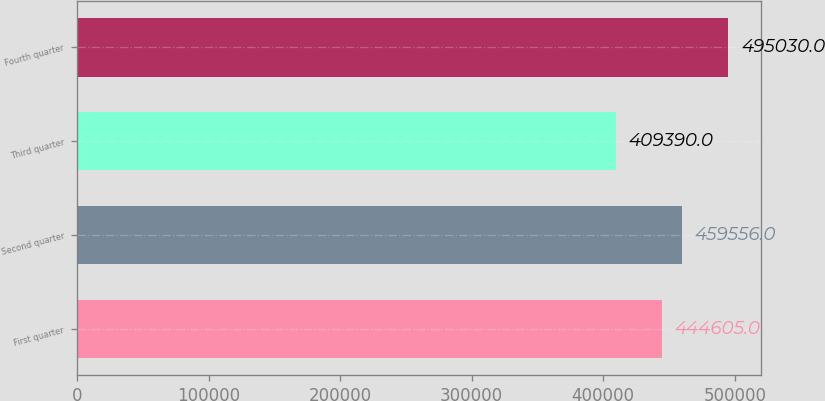<chart> <loc_0><loc_0><loc_500><loc_500><bar_chart><fcel>First quarter<fcel>Second quarter<fcel>Third quarter<fcel>Fourth quarter<nl><fcel>444605<fcel>459556<fcel>409390<fcel>495030<nl></chart> 